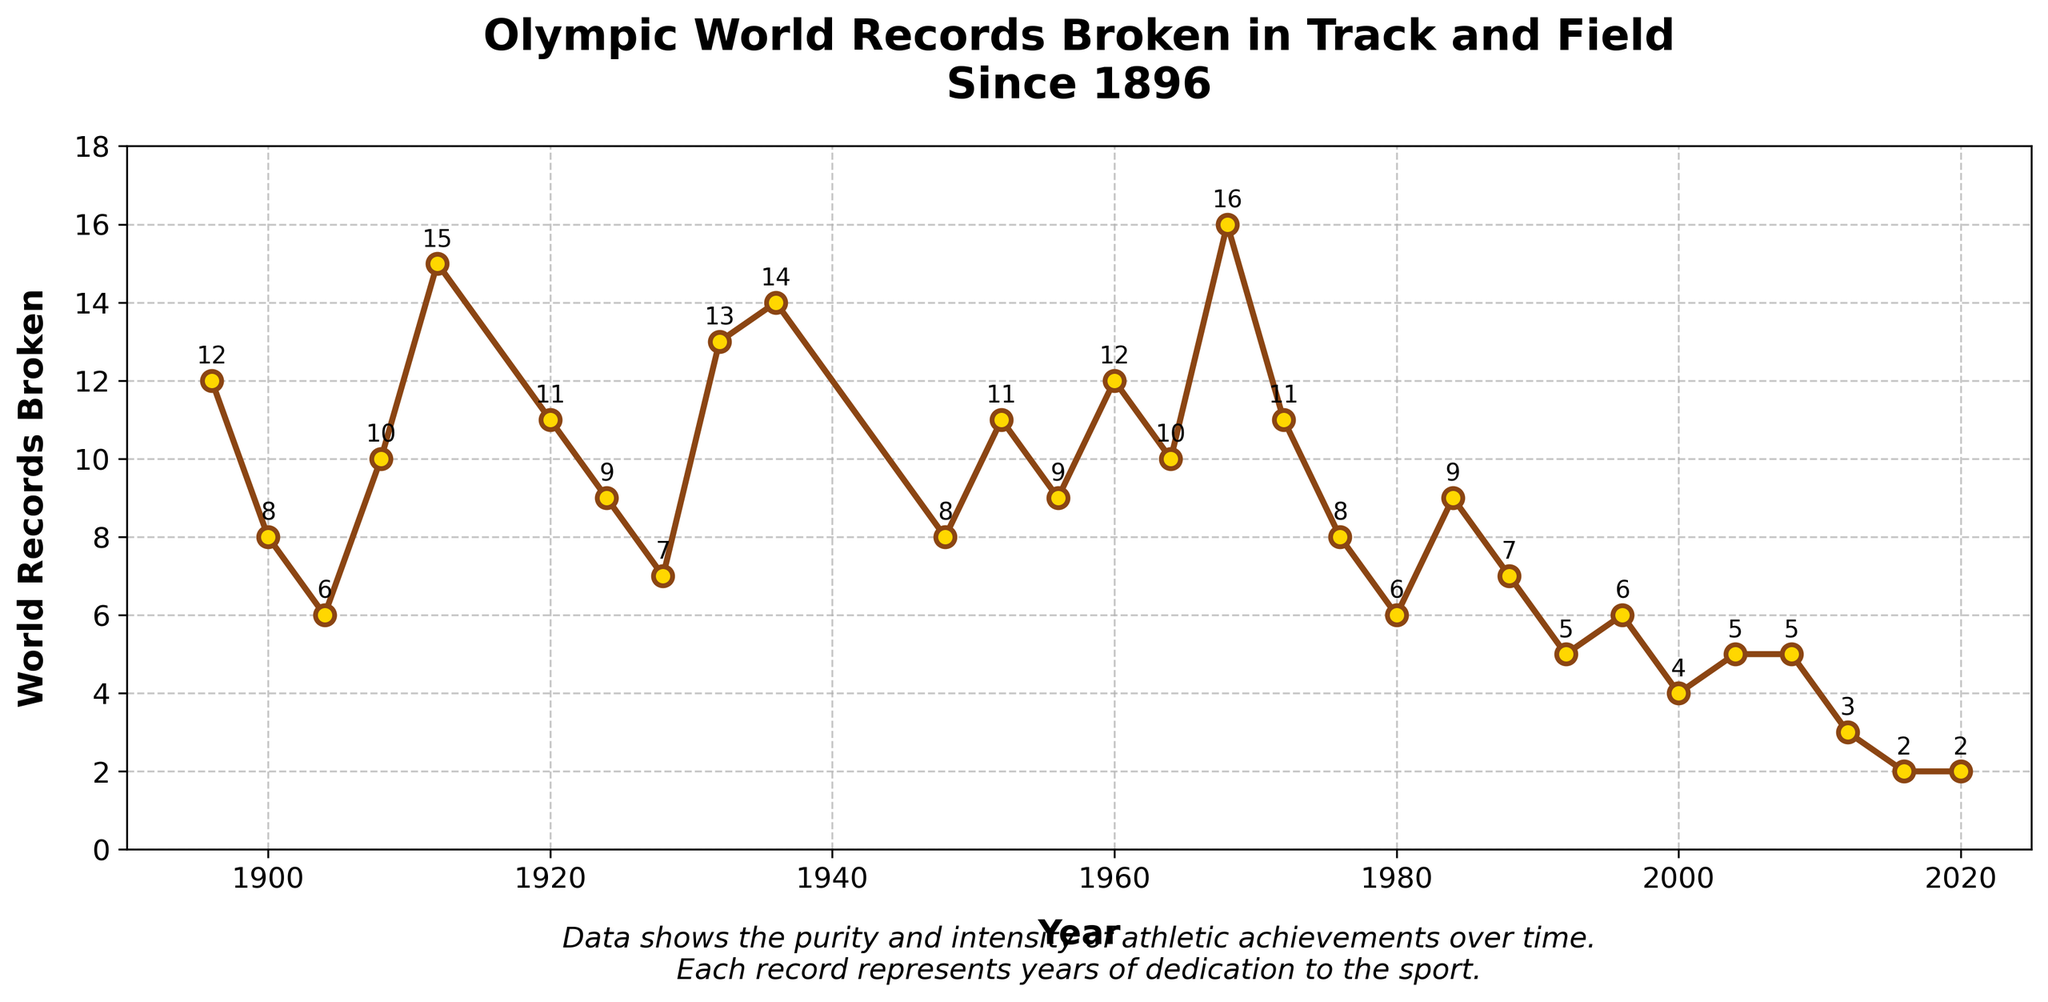Which year had the highest number of Olympic world records broken? By looking at the peaks on the line chart, the highest point corresponds to the year 1968 with 16 records broken.
Answer: 1968 During which years were fewer than 5 world records broken? Observing the line chart, the years where the records are at or below 5 are 1992, 2000, 2004, 2008, 2012, 2016, and 2020.
Answer: 1992, 2000, 2004, 2008, 2012, 2016, 2020 How many world records were broken in the years 1936 and 1960 combined? By checking the markers for the years 1936 and 1960, we see 14 records in 1936 and 12 in 1960. Adding them up, we get 14 + 12 = 26.
Answer: 26 Compare the world records broken in 1920 and 1976. In which year were more records broken? The line chart shows that 11 world records were broken in 1920 and 8 in 1976. Since 11 is greater than 8, more records were broken in 1920.
Answer: 1920 What was the overall trend in the number of world records broken from 1896 to 2020? Observing the line chart from left to right, there is a general downward trend in the number of records broken, with peaks and troughs occurring intermittently.
Answer: Downward How many years had exactly 8 world records broken? Checking the chart, we see the years 1900, 1948, and 1976 each have exactly 8 records broken, thus there are 3 such years.
Answer: 3 In which years was the number of world records broken more than 15? According to the chart, there is only one year where the number of records exceeds 15, which is 1968.
Answer: 1968 What were the values of world records broken in the Olympic Games held immediately before and after 1936? The Olympics held before 1936 was in 1932 with 13 records broken, and after 1936 was in 1948 with 8 records broken.
Answer: 1932: 13, 1948: 8 